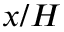<formula> <loc_0><loc_0><loc_500><loc_500>x / H</formula> 